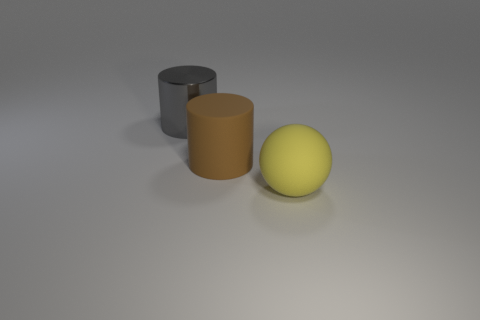What is the color of the large ball?
Your answer should be very brief. Yellow. What shape is the large yellow thing that is the same material as the brown object?
Your answer should be compact. Sphere. How many things are either cylinders that are right of the metal cylinder or cylinders to the right of the big metal thing?
Provide a succinct answer. 1. What number of matte things are either large blue objects or cylinders?
Your answer should be compact. 1. What is the shape of the large yellow matte thing?
Provide a short and direct response. Sphere. Is there any other thing that has the same material as the big gray cylinder?
Give a very brief answer. No. Do the big gray cylinder and the large brown cylinder have the same material?
Keep it short and to the point. No. There is a big cylinder that is left of the large rubber object that is behind the yellow rubber object; are there any brown cylinders that are left of it?
Offer a very short reply. No. What number of other objects are the same shape as the yellow matte thing?
Make the answer very short. 0. What shape is the object that is left of the yellow rubber thing and right of the big metal cylinder?
Your answer should be compact. Cylinder. 